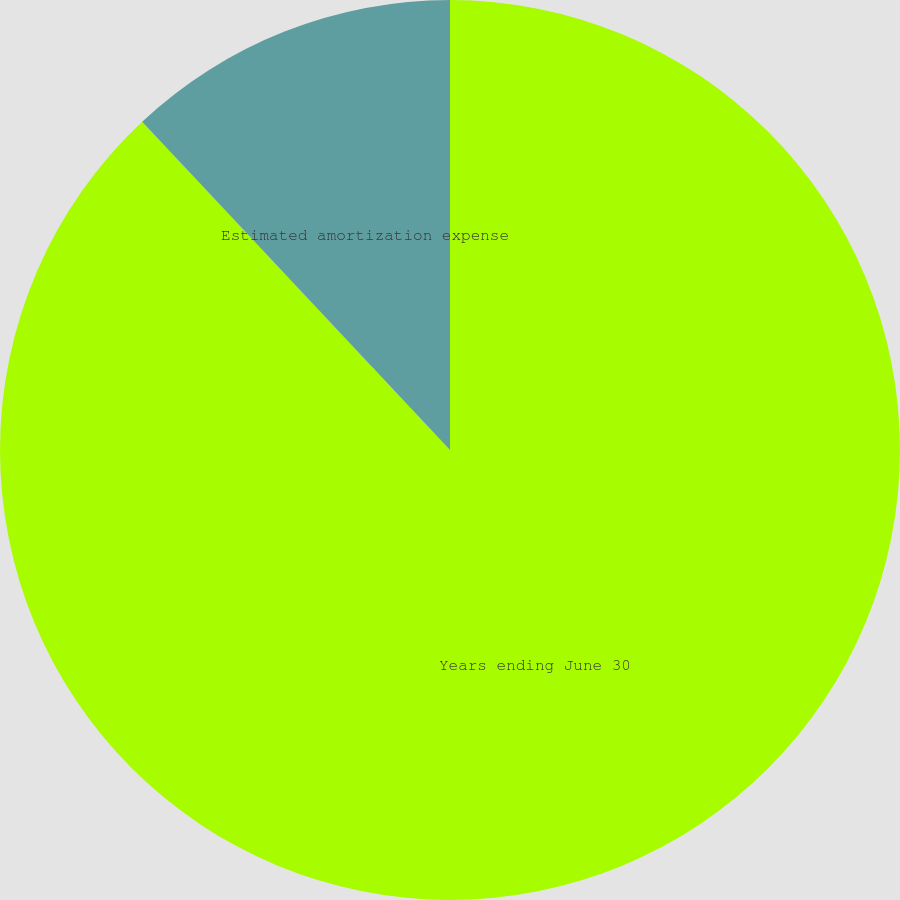Convert chart. <chart><loc_0><loc_0><loc_500><loc_500><pie_chart><fcel>Years ending June 30<fcel>Estimated amortization expense<nl><fcel>88.01%<fcel>11.99%<nl></chart> 